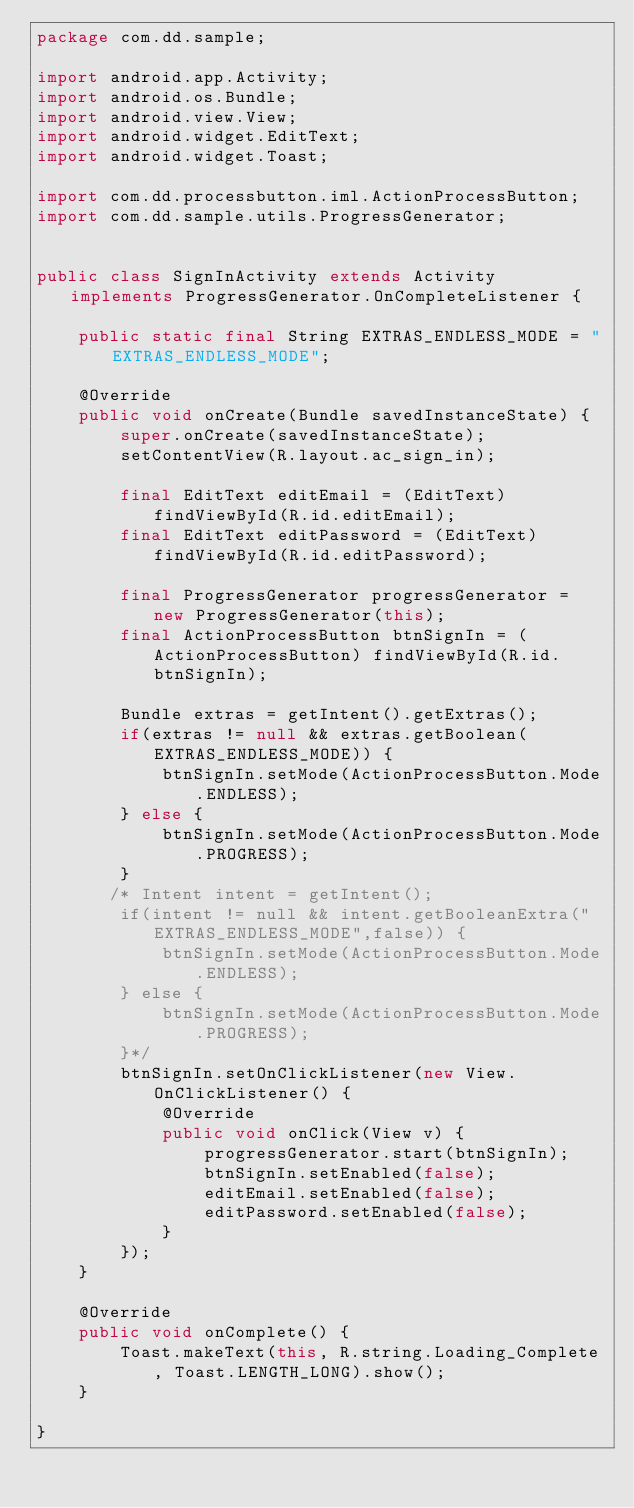<code> <loc_0><loc_0><loc_500><loc_500><_Java_>package com.dd.sample;

import android.app.Activity;
import android.os.Bundle;
import android.view.View;
import android.widget.EditText;
import android.widget.Toast;

import com.dd.processbutton.iml.ActionProcessButton;
import com.dd.sample.utils.ProgressGenerator;


public class SignInActivity extends Activity implements ProgressGenerator.OnCompleteListener {

    public static final String EXTRAS_ENDLESS_MODE = "EXTRAS_ENDLESS_MODE";

    @Override
    public void onCreate(Bundle savedInstanceState) {
        super.onCreate(savedInstanceState);
        setContentView(R.layout.ac_sign_in);

        final EditText editEmail = (EditText) findViewById(R.id.editEmail);
        final EditText editPassword = (EditText) findViewById(R.id.editPassword);

        final ProgressGenerator progressGenerator = new ProgressGenerator(this);
        final ActionProcessButton btnSignIn = (ActionProcessButton) findViewById(R.id.btnSignIn);

        Bundle extras = getIntent().getExtras();
        if(extras != null && extras.getBoolean(EXTRAS_ENDLESS_MODE)) {
            btnSignIn.setMode(ActionProcessButton.Mode.ENDLESS);
        } else {
            btnSignIn.setMode(ActionProcessButton.Mode.PROGRESS);
        }
       /* Intent intent = getIntent();
        if(intent != null && intent.getBooleanExtra("EXTRAS_ENDLESS_MODE",false)) {
            btnSignIn.setMode(ActionProcessButton.Mode.ENDLESS);
        } else {
            btnSignIn.setMode(ActionProcessButton.Mode.PROGRESS);
        }*/
        btnSignIn.setOnClickListener(new View.OnClickListener() {
            @Override
            public void onClick(View v) {
                progressGenerator.start(btnSignIn);
                btnSignIn.setEnabled(false);
                editEmail.setEnabled(false);
                editPassword.setEnabled(false);
            }
        });
    }

    @Override
    public void onComplete() {
        Toast.makeText(this, R.string.Loading_Complete, Toast.LENGTH_LONG).show();
    }

}
</code> 